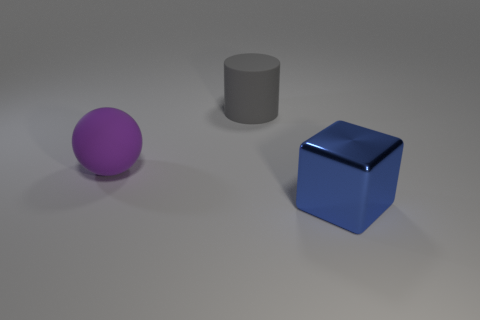What number of gray rubber cylinders have the same size as the metallic thing?
Your response must be concise. 1. Is the number of things that are behind the purple rubber thing less than the number of big purple matte things on the right side of the block?
Give a very brief answer. No. Are there any large gray rubber objects that have the same shape as the blue shiny object?
Your answer should be very brief. No. Is the shape of the large blue metal thing the same as the gray thing?
Your answer should be very brief. No. How many small objects are blue spheres or cylinders?
Offer a terse response. 0. Are there more cyan balls than purple rubber balls?
Your answer should be compact. No. There is a gray object that is made of the same material as the purple object; what is its size?
Ensure brevity in your answer.  Large. Is the size of the thing right of the gray rubber thing the same as the object that is to the left of the large gray cylinder?
Your response must be concise. Yes. How many things are either things to the left of the big blue metallic block or large purple things?
Your response must be concise. 2. Is the number of big things less than the number of big purple balls?
Offer a very short reply. No. 